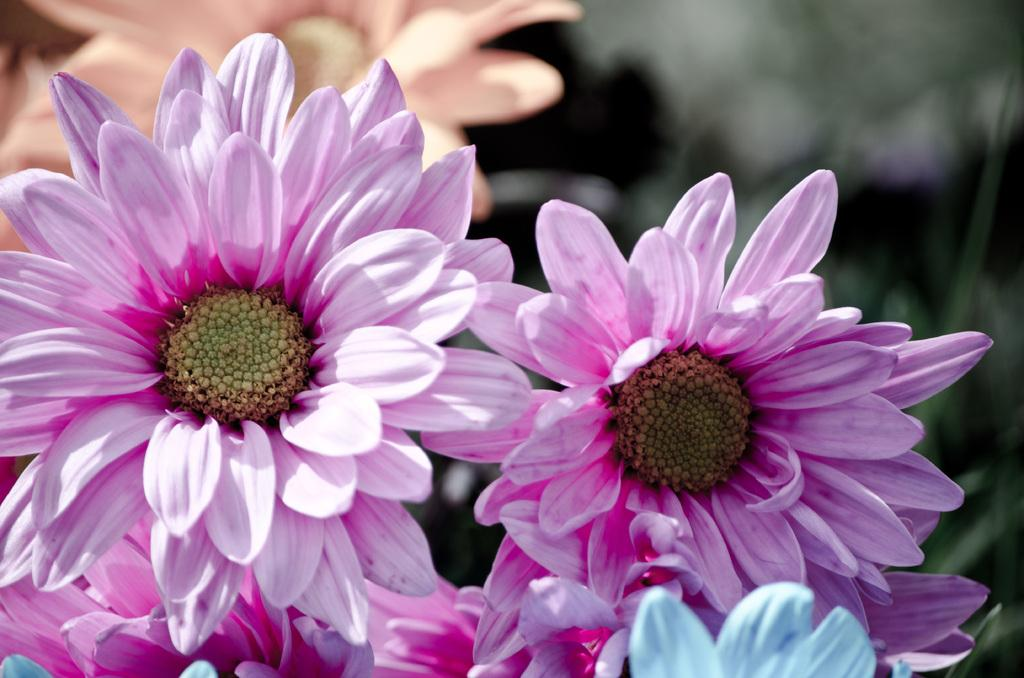What type of plants can be seen in the image? There are flowers in the image. Can you describe the quality of the image in the top right corner? The top right corner of the image is blurry. What type of amusement can be seen in the image? There is no amusement present in the image; it features flowers and a blurry corner. What is the comb used for in the image? There is no comb present in the image. 